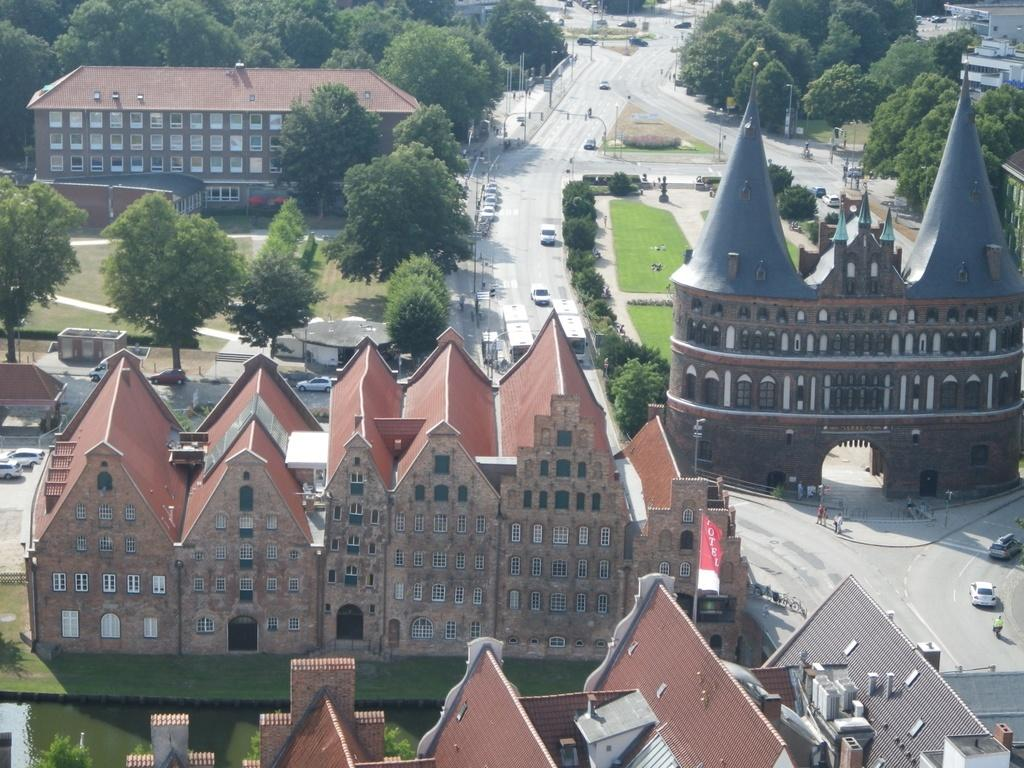What type of establishment is depicted in the picture? There is a museum in the picture. What can be seen surrounding the museum? There are trees, gardens, roads, and other huge buildings in the vicinity of the museum. Can you describe the landscape around the museum? The museum is surrounded by trees and gardens, suggesting a natural environment. How is the museum connected to the surrounding area? Roads are present around the museum, indicating that it is accessible by vehicle. What type of silk can be seen on the donkey in the image? There is no donkey or silk present in the image; it features a museum surrounded by trees, gardens, roads, and other buildings. 